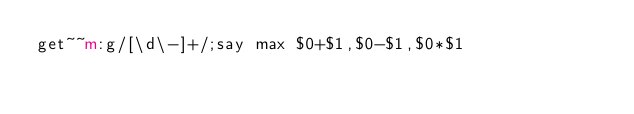Convert code to text. <code><loc_0><loc_0><loc_500><loc_500><_Perl_>get~~m:g/[\d\-]+/;say max $0+$1,$0-$1,$0*$1</code> 